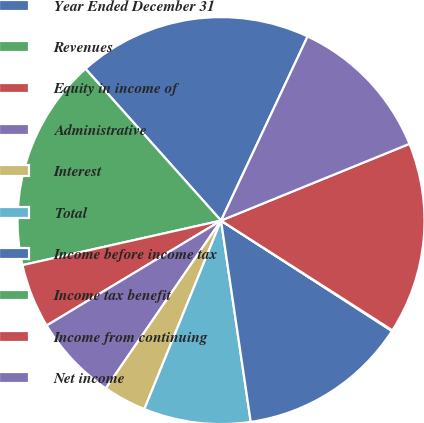Convert chart. <chart><loc_0><loc_0><loc_500><loc_500><pie_chart><fcel>Year Ended December 31<fcel>Revenues<fcel>Equity in income of<fcel>Administrative<fcel>Interest<fcel>Total<fcel>Income before income tax<fcel>Income tax benefit<fcel>Income from continuing<fcel>Net income<nl><fcel>18.59%<fcel>16.91%<fcel>5.11%<fcel>6.8%<fcel>3.43%<fcel>8.48%<fcel>13.54%<fcel>0.06%<fcel>15.22%<fcel>11.85%<nl></chart> 